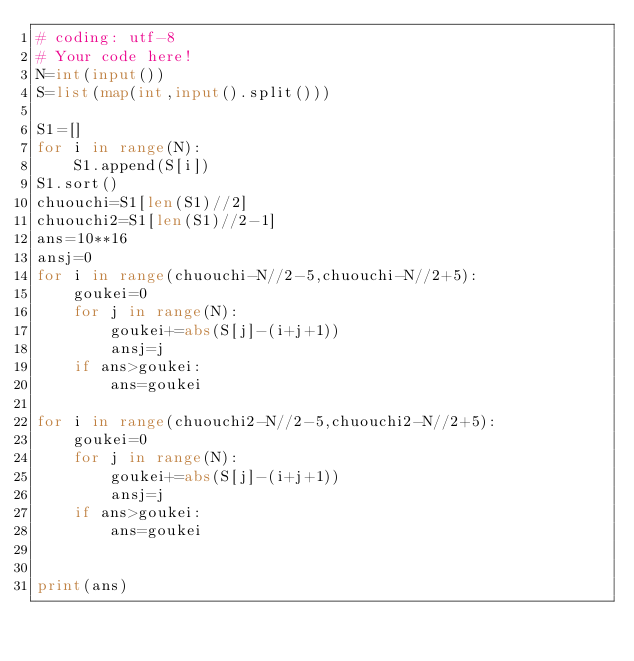<code> <loc_0><loc_0><loc_500><loc_500><_Python_># coding: utf-8
# Your code here!
N=int(input())
S=list(map(int,input().split()))

S1=[]
for i in range(N):
    S1.append(S[i])
S1.sort()
chuouchi=S1[len(S1)//2]
chuouchi2=S1[len(S1)//2-1]
ans=10**16
ansj=0
for i in range(chuouchi-N//2-5,chuouchi-N//2+5):
    goukei=0
    for j in range(N):
        goukei+=abs(S[j]-(i+j+1))
        ansj=j
    if ans>goukei:
        ans=goukei
        
for i in range(chuouchi2-N//2-5,chuouchi2-N//2+5):
    goukei=0
    for j in range(N):
        goukei+=abs(S[j]-(i+j+1))
        ansj=j
    if ans>goukei:
        ans=goukei
        
        
print(ans)
</code> 